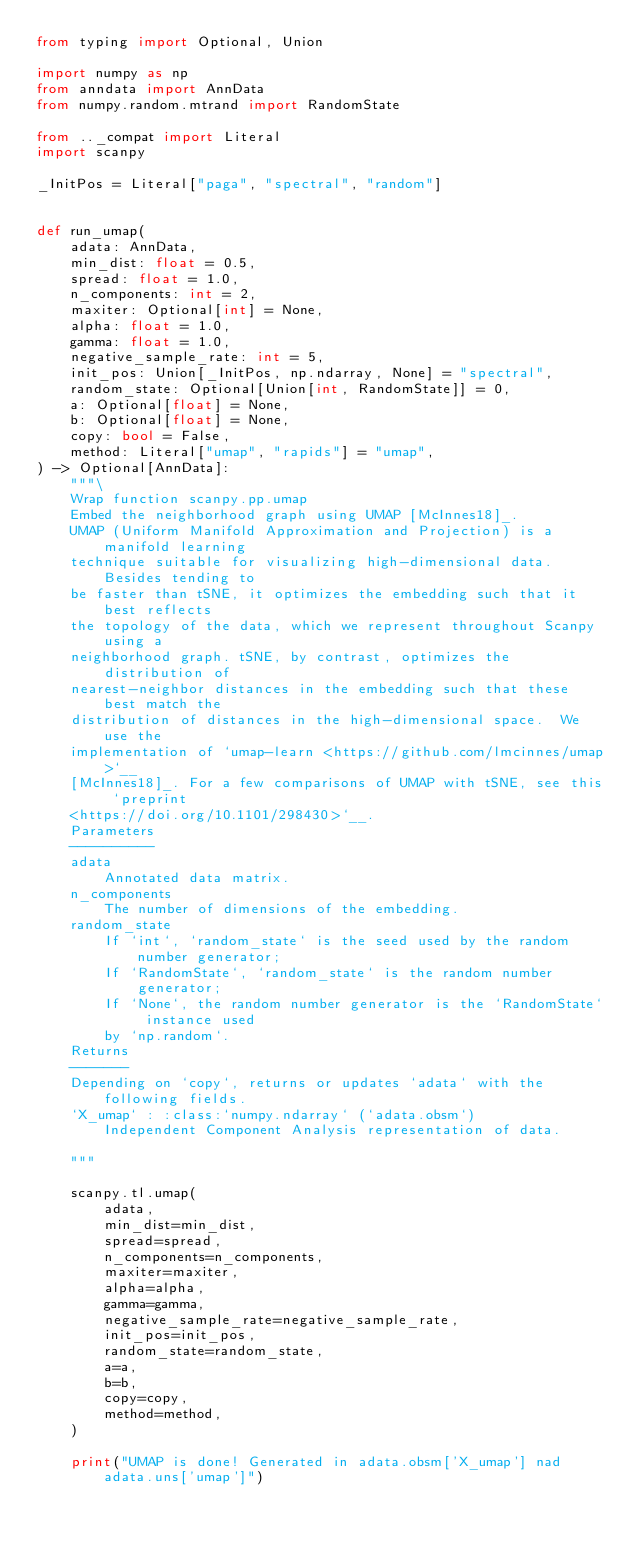<code> <loc_0><loc_0><loc_500><loc_500><_Python_>from typing import Optional, Union

import numpy as np
from anndata import AnnData
from numpy.random.mtrand import RandomState

from .._compat import Literal
import scanpy

_InitPos = Literal["paga", "spectral", "random"]


def run_umap(
    adata: AnnData,
    min_dist: float = 0.5,
    spread: float = 1.0,
    n_components: int = 2,
    maxiter: Optional[int] = None,
    alpha: float = 1.0,
    gamma: float = 1.0,
    negative_sample_rate: int = 5,
    init_pos: Union[_InitPos, np.ndarray, None] = "spectral",
    random_state: Optional[Union[int, RandomState]] = 0,
    a: Optional[float] = None,
    b: Optional[float] = None,
    copy: bool = False,
    method: Literal["umap", "rapids"] = "umap",
) -> Optional[AnnData]:
    """\
    Wrap function scanpy.pp.umap
    Embed the neighborhood graph using UMAP [McInnes18]_.
    UMAP (Uniform Manifold Approximation and Projection) is a manifold learning
    technique suitable for visualizing high-dimensional data. Besides tending to
    be faster than tSNE, it optimizes the embedding such that it best reflects
    the topology of the data, which we represent throughout Scanpy using a
    neighborhood graph. tSNE, by contrast, optimizes the distribution of
    nearest-neighbor distances in the embedding such that these best match the
    distribution of distances in the high-dimensional space.  We use the
    implementation of `umap-learn <https://github.com/lmcinnes/umap>`__
    [McInnes18]_. For a few comparisons of UMAP with tSNE, see this `preprint
    <https://doi.org/10.1101/298430>`__.
    Parameters
    ----------
    adata
        Annotated data matrix.
    n_components
        The number of dimensions of the embedding.
    random_state
        If `int`, `random_state` is the seed used by the random number generator;
        If `RandomState`, `random_state` is the random number generator;
        If `None`, the random number generator is the `RandomState` instance used
        by `np.random`.
    Returns
    -------
    Depending on `copy`, returns or updates `adata` with the following fields.
    `X_umap` : :class:`numpy.ndarray` (`adata.obsm`)
        Independent Component Analysis representation of data.

    """

    scanpy.tl.umap(
        adata,
        min_dist=min_dist,
        spread=spread,
        n_components=n_components,
        maxiter=maxiter,
        alpha=alpha,
        gamma=gamma,
        negative_sample_rate=negative_sample_rate,
        init_pos=init_pos,
        random_state=random_state,
        a=a,
        b=b,
        copy=copy,
        method=method,
    )

    print("UMAP is done! Generated in adata.obsm['X_umap'] nad adata.uns['umap']")
</code> 